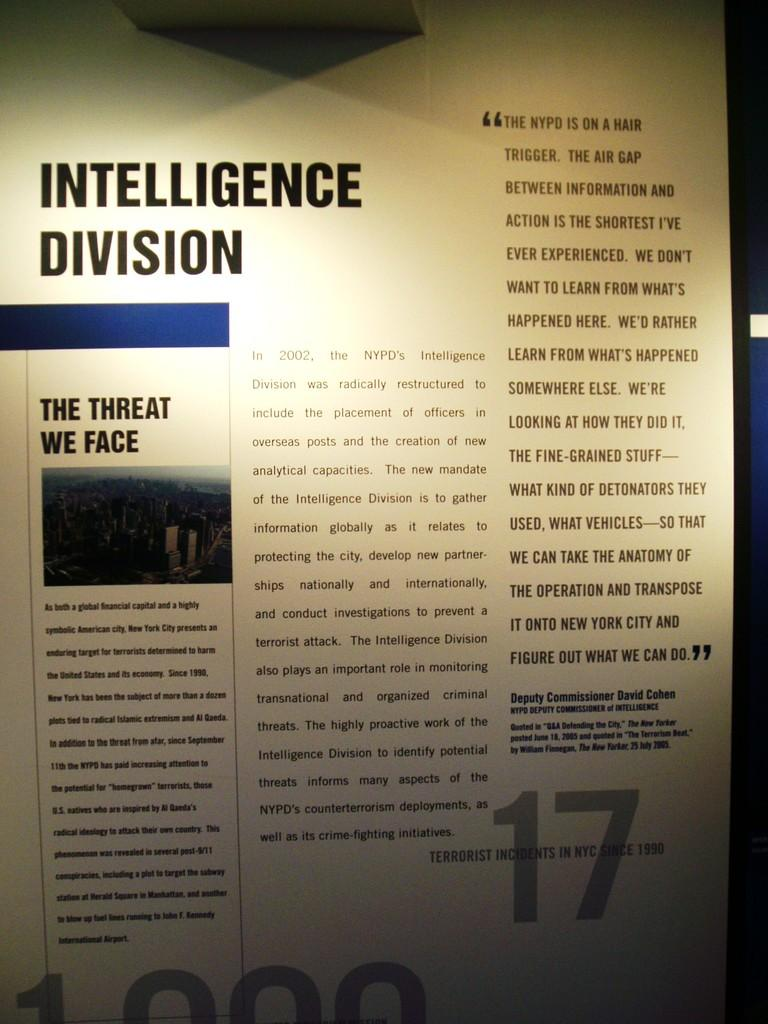What is present on the paper in the image? There is text on a paper in the image. What type of yarn is being used to create the dress in the image? There is no dress or yarn present in the image; it only features text on a paper. What is the horsepower of the engine in the image? There is no engine present in the image; it only features text on a paper. 